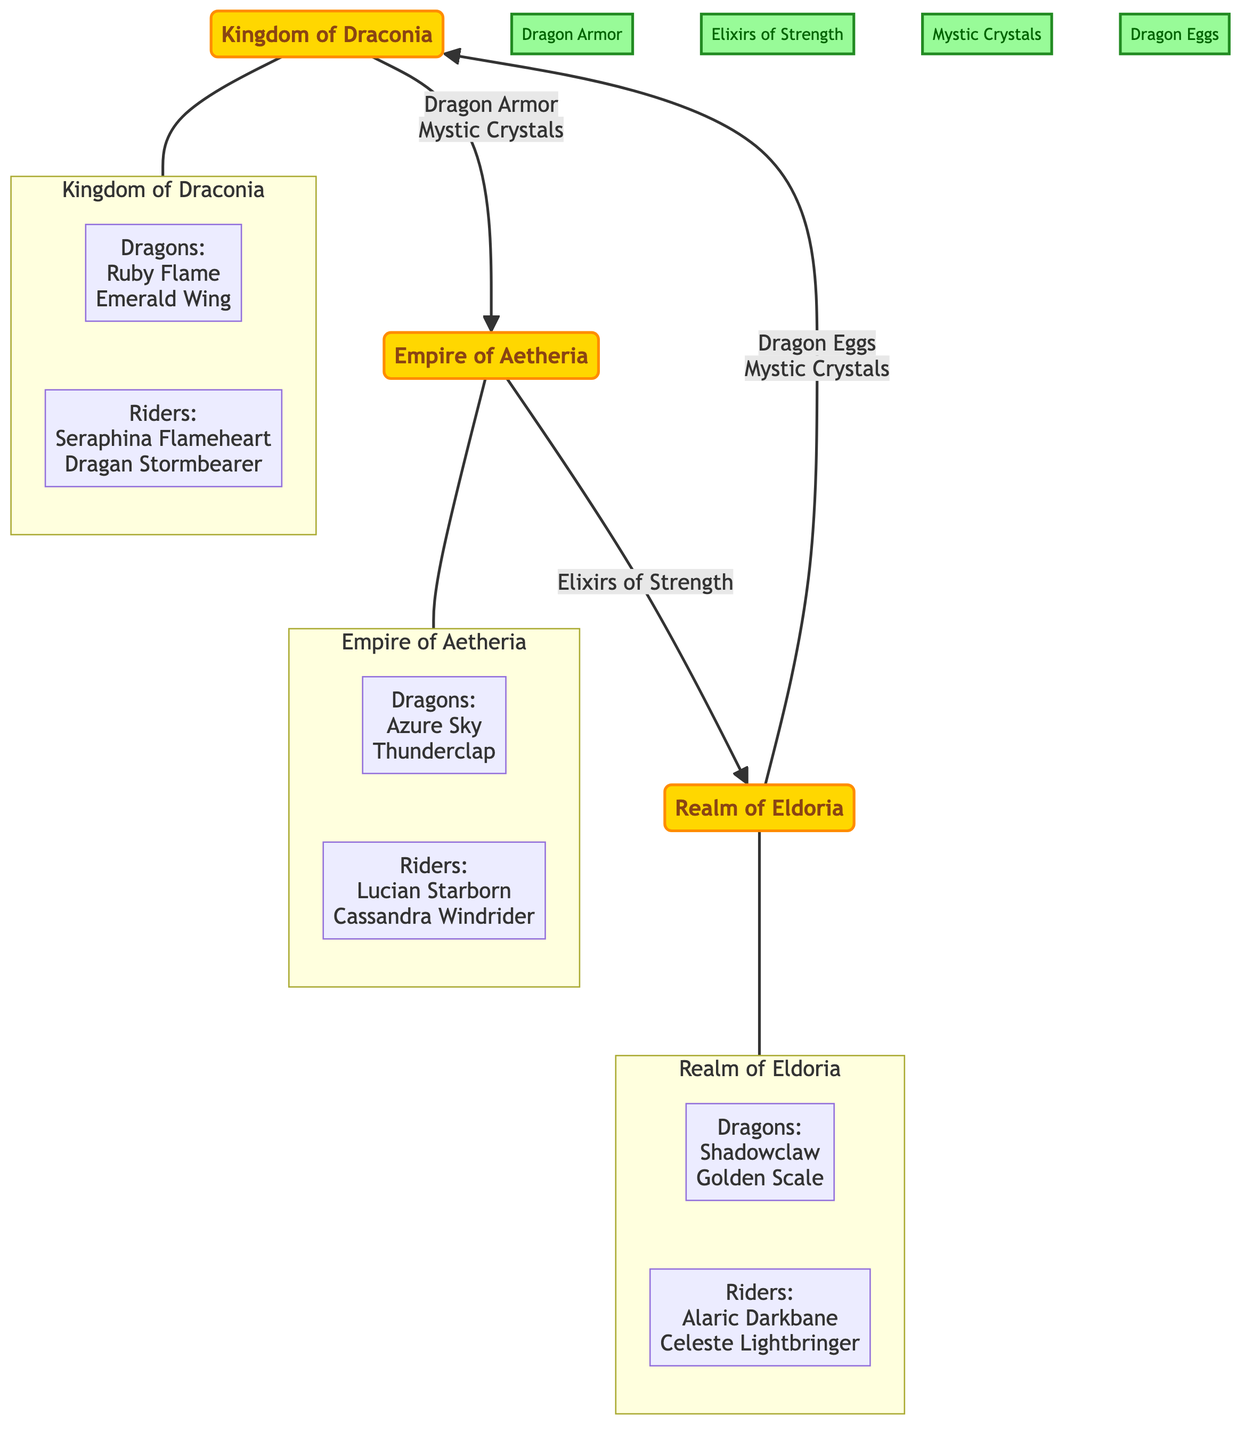What kingdoms are involved in trade? The diagram displays three kingdoms: Kingdom of Draconia, Empire of Aetheria, and Realm of Eldoria. These names can be identified as the primary nodes representing the kingdoms in the network.
Answer: Kingdom of Draconia, Empire of Aetheria, Realm of Eldoria How many trade goods are listed? The diagram includes four trade goods shown as nodes: Dragon Armor, Elixirs of Strength, Mystic Crystals, and Dragon Eggs. By counting these goods, we find there are a total of four.
Answer: 4 Which goods are traded from Kingdom of Draconia to Empire of Aetheria? The trade route from Kingdom of Draconia to Empire of Aetheria lists two goods: Dragon Armor and Mystic Crystals. These items appear as a label on the connecting edge in the diagram.
Answer: Dragon Armor, Mystic Crystals Who is the rider from Empire of Aetheria? The diagram provides two riders listed for the Empire of Aetheria: Lucian Starborn and Cassandra Windrider. Since the question asks specifically for one, either can be the answer.
Answer: Lucian Starborn What is the direction of the trade route from Empire of Aetheria to Realm of Eldoria? The trade route is represented with an arrow pointing from Empire of Aetheria to Realm of Eldoria, indicating that goods are sent from Aetheria to Eldoria. The type of goods sent in this direction is Elixirs of Strength.
Answer: Aetheria to Eldoria Which kingdom sends Dragon Eggs? Looking at the trade routes, Dragon Eggs are sent from the Realm of Eldoria to the Kingdom of Draconia. By observing the connection direction, it is clear which kingdom initiates this trade.
Answer: Realm of Eldoria What two goods does the Realm of Eldoria send to the Kingdom of Draconia? The trade route from Realm of Eldoria to Kingdom of Draconia indicates that they send Dragon Eggs and Mystic Crystals. By examining the connection, we find these two goods listed side by side.
Answer: Dragon Eggs, Mystic Crystals How many edges are there in the diagram? The diagram contains three distinct trade routes (edges) connecting the three kingdoms. Each route represents a connection for trading goods. By counting these edges, we realize there are three trades depicted.
Answer: 3 